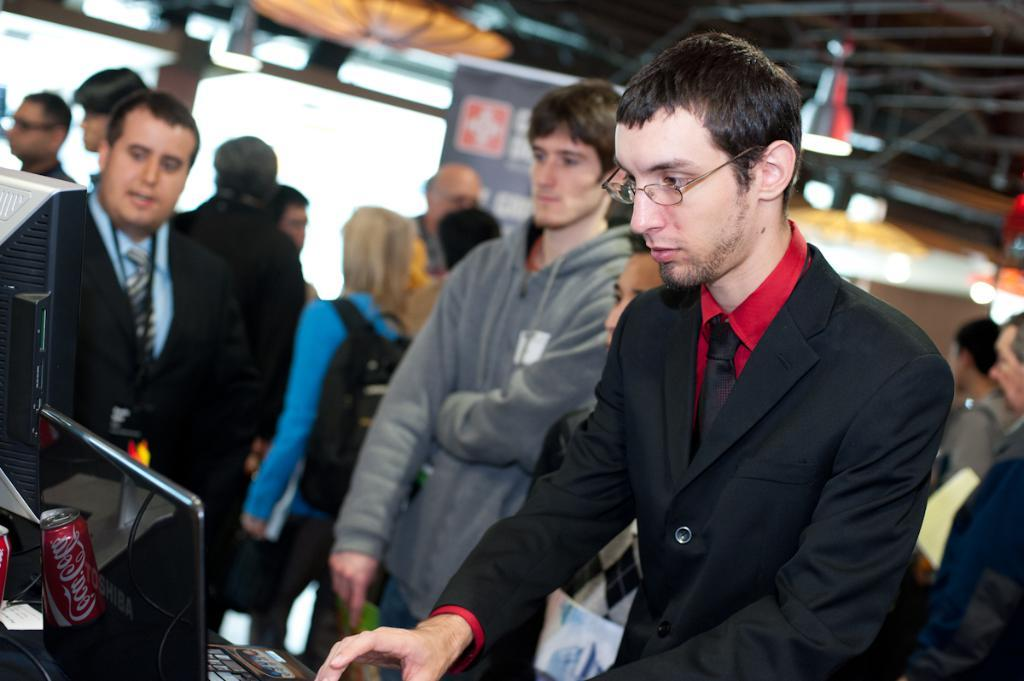What is the man on the right side of the image doing? The man is standing on the right side of the image. What is the man wearing on his upper body? The man is wearing a black coat and a red shirt. What type of accessory is the man wearing around his neck? The man is wearing a tie. Are there any other people in the image besides the man on the right side? Yes, there are other people present in the image. Can you describe the fog in the image? There is no fog present in the image. What type of chair is the man sitting on in the image? The man is standing, not sitting, and there is no chair present in the image. 